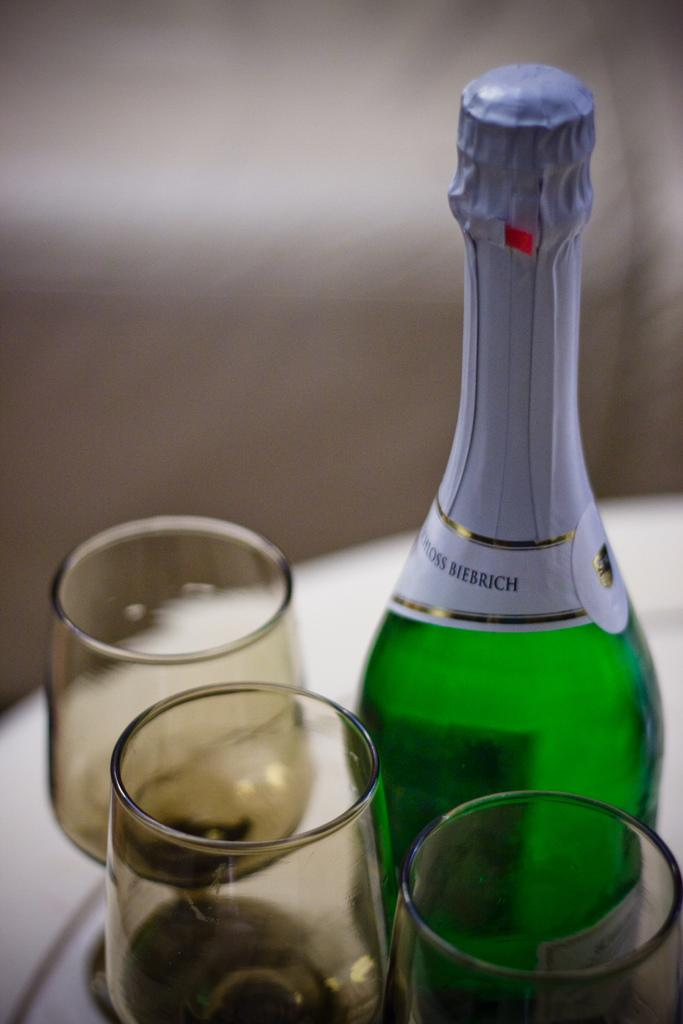What is one of the objects visible in the image? There is a bottle in the image. What else can be seen in the image besides the bottle? There are glasses in the image. How many sails are visible on the bottle in the image? There are no sails present on the bottle in the image. Can you tell me how many ants are crawling on the glasses in the image? There are no ants present on the glasses in the image. 